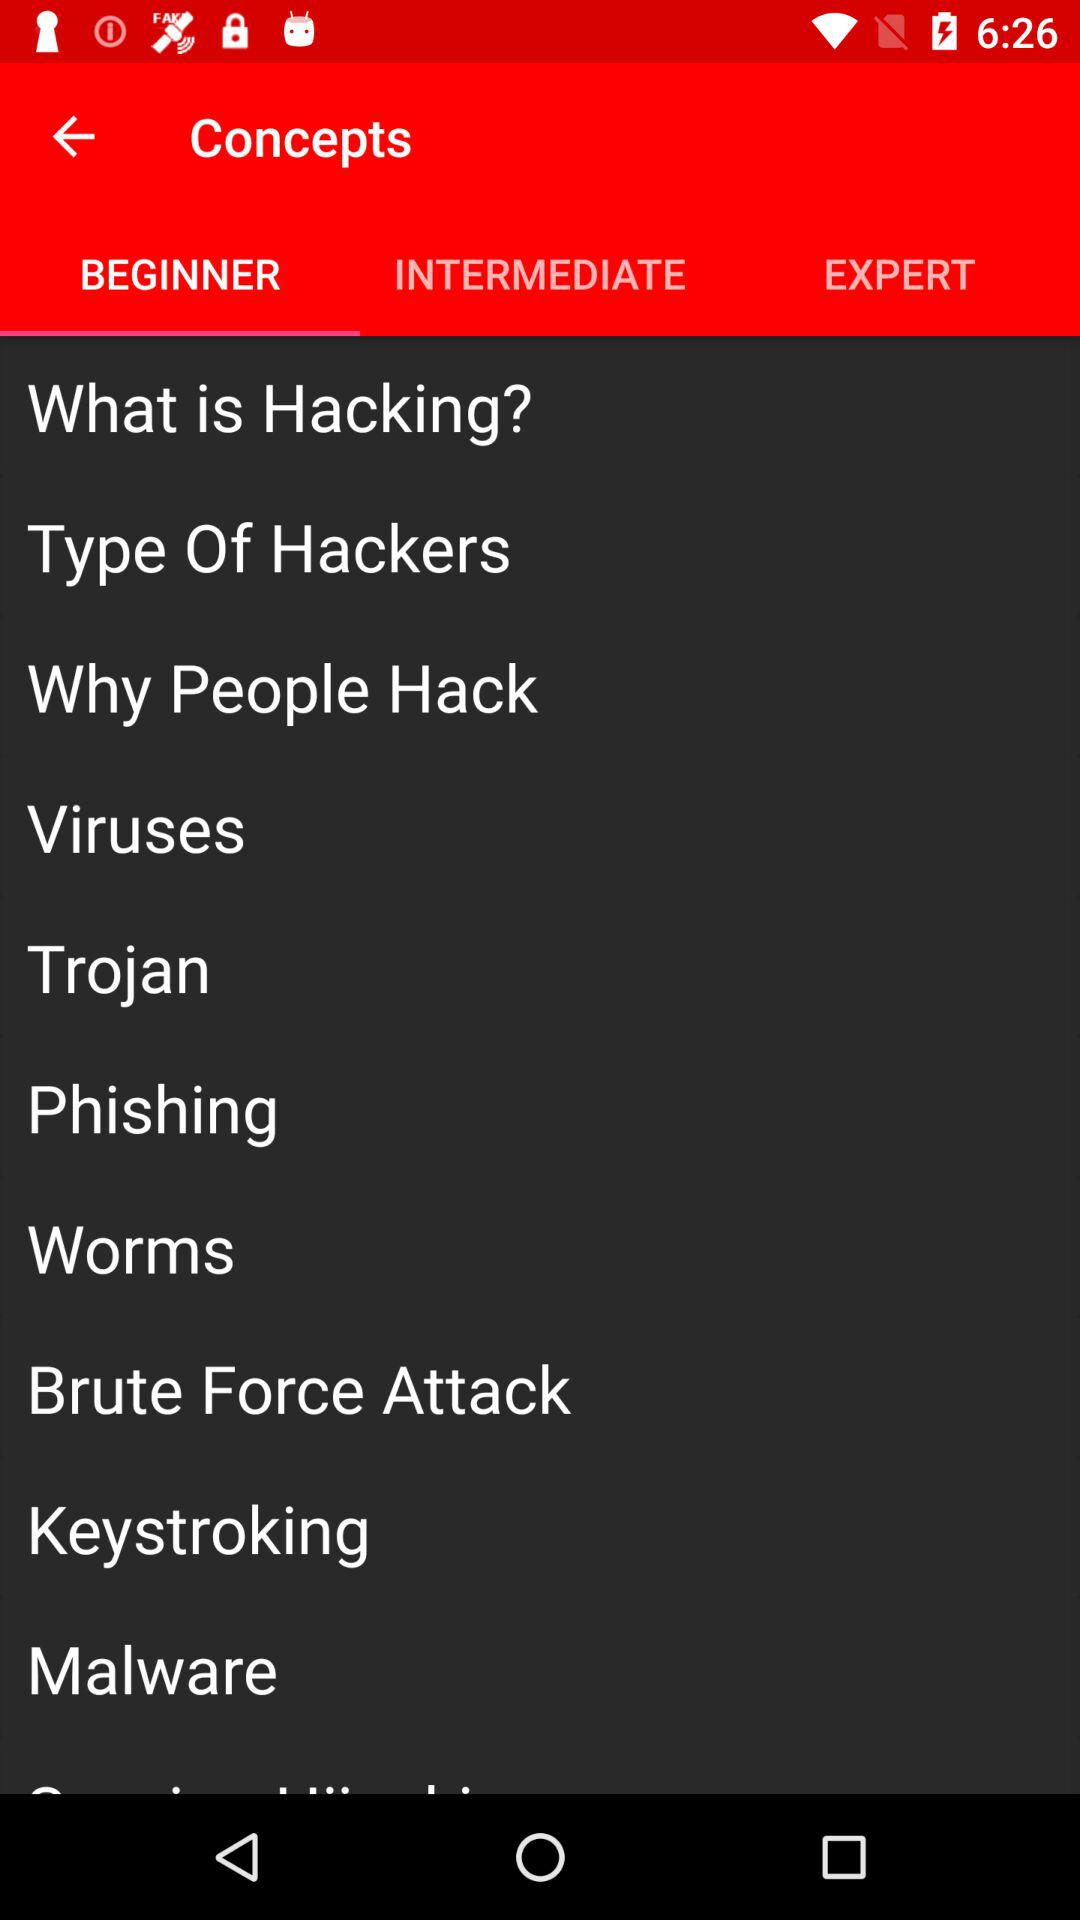How many levels of difficulty are there?
Answer the question using a single word or phrase. 3 